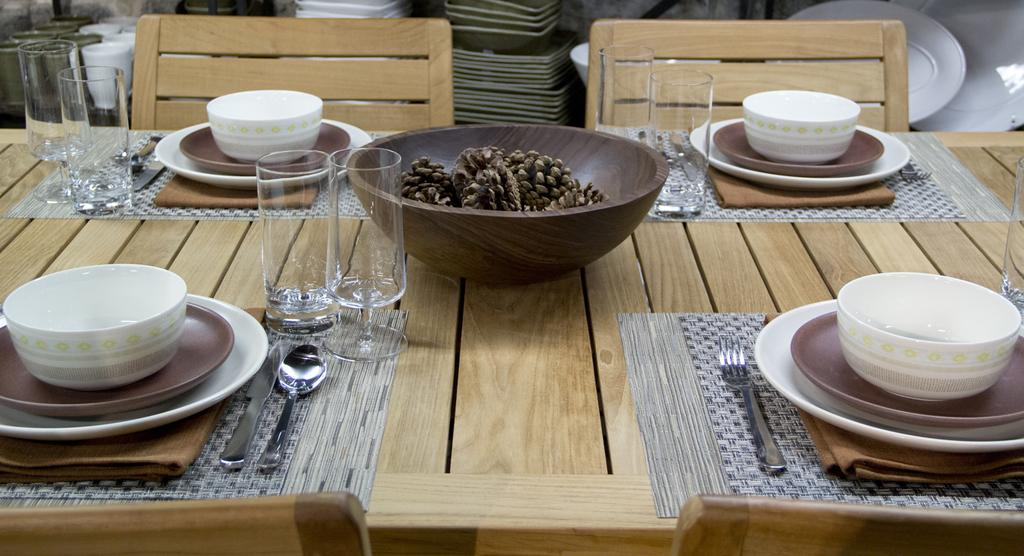What piece of furniture is present in the image? There is a table in the image. What items are placed on the table? There are bowls, spoons, and glasses on the table. How are people expected to sit around the table? Chairs are arranged around the table. Is there any dust visible on the table in the image? There is no mention of dust in the provided facts, so we cannot determine if dust is visible in the image. Can you see any snow falling outside the window in the image? There is no mention of a window or snow in the provided facts, so we cannot determine if snow is visible in the image. 